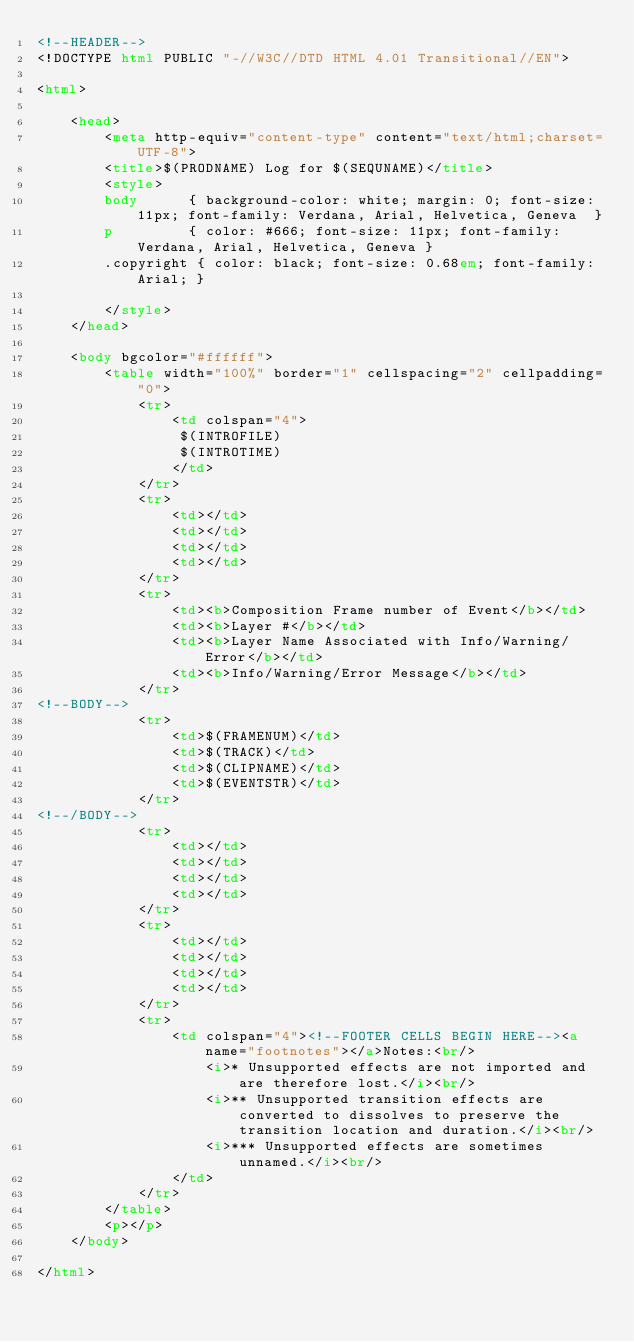<code> <loc_0><loc_0><loc_500><loc_500><_HTML_><!--HEADER-->
<!DOCTYPE html PUBLIC "-//W3C//DTD HTML 4.01 Transitional//EN">

<html>

	<head>
		<meta http-equiv="content-type" content="text/html;charset=UTF-8">
		<title>$(PRODNAME) Log for $(SEQUNAME)</title>
		<style>
		body      { background-color: white; margin: 0; font-size: 11px; font-family: Verdana, Arial, Helvetica, Geneva  }
		p         { color: #666; font-size: 11px; font-family: Verdana, Arial, Helvetica, Geneva }
		.copyright { color: black; font-size: 0.68em; font-family: Arial; }

		</style>
	</head>

	<body bgcolor="#ffffff">
		<table width="100%" border="1" cellspacing="2" cellpadding="0">
			<tr>
				<td colspan="4">
				 $(INTROFILE)
				 $(INTROTIME)
				</td>
			</tr>
			<tr>
				<td></td>
				<td></td>
				<td></td>
				<td></td>
			</tr>
			<tr>
				<td><b>Composition Frame number of Event</b></td>
				<td><b>Layer #</b></td>
				<td><b>Layer Name Associated with Info/Warning/Error</b></td>
				<td><b>Info/Warning/Error Message</b></td>
			</tr>
<!--BODY-->
			<tr>
				<td>$(FRAMENUM)</td>
				<td>$(TRACK)</td>
				<td>$(CLIPNAME)</td>
				<td>$(EVENTSTR)</td>
			</tr>
<!--/BODY-->
			<tr>
				<td></td>
				<td></td>
				<td></td>
				<td></td>
			</tr>
			<tr>
				<td></td>
				<td></td>
				<td></td>
				<td></td>
			</tr>
			<tr>
				<td colspan="4"><!--FOOTER CELLS BEGIN HERE--><a name="footnotes"></a>Notes:<br/>
					<i>* Unsupported effects are not imported and are therefore lost.</i><br/>
					<i>** Unsupported transition effects are converted to dissolves to preserve the transition location and duration.</i><br/>
					<i>*** Unsupported effects are sometimes unnamed.</i><br/>
				</td>
			</tr>
		</table>
		<p></p>
	</body>

</html></code> 